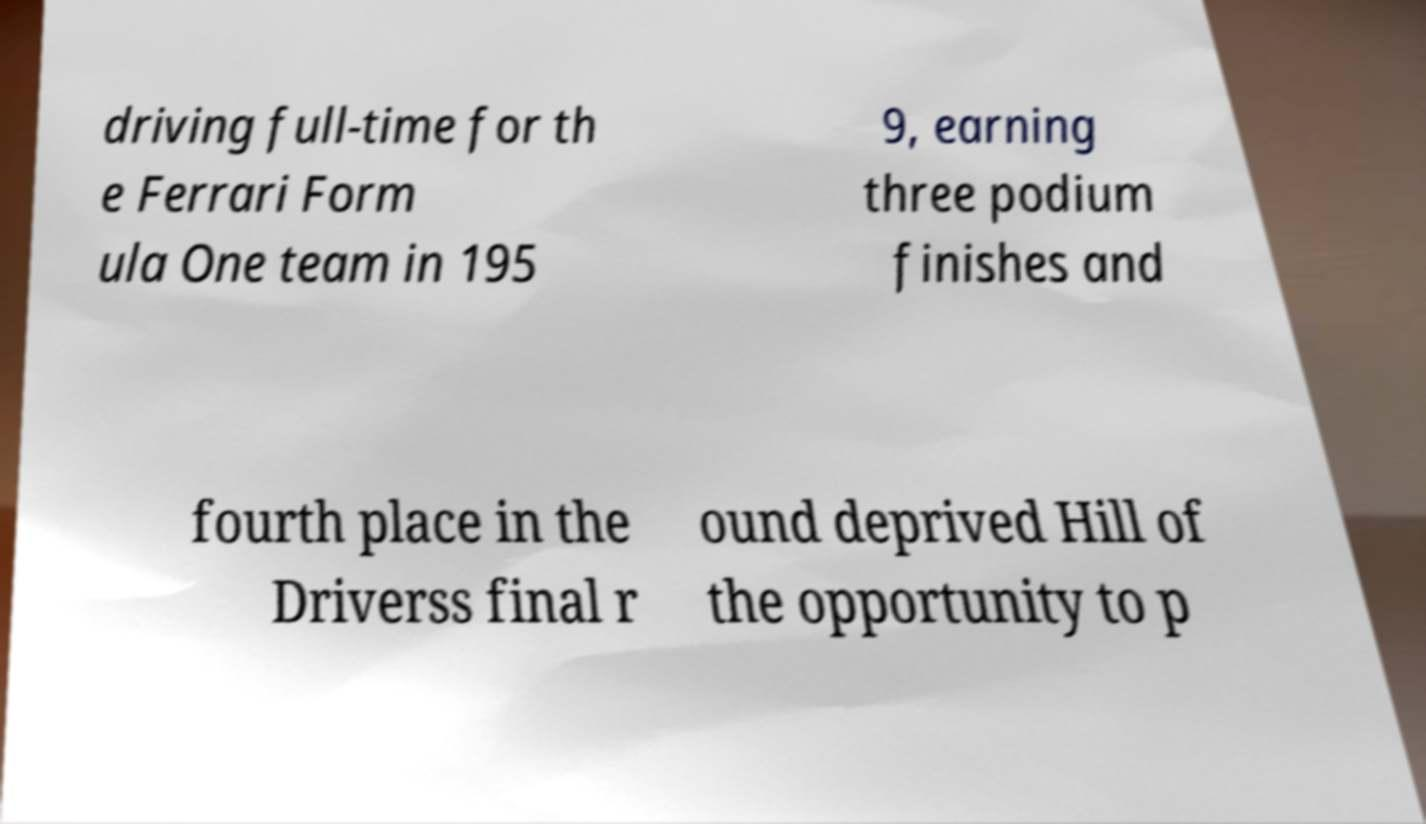Can you accurately transcribe the text from the provided image for me? driving full-time for th e Ferrari Form ula One team in 195 9, earning three podium finishes and fourth place in the Driverss final r ound deprived Hill of the opportunity to p 